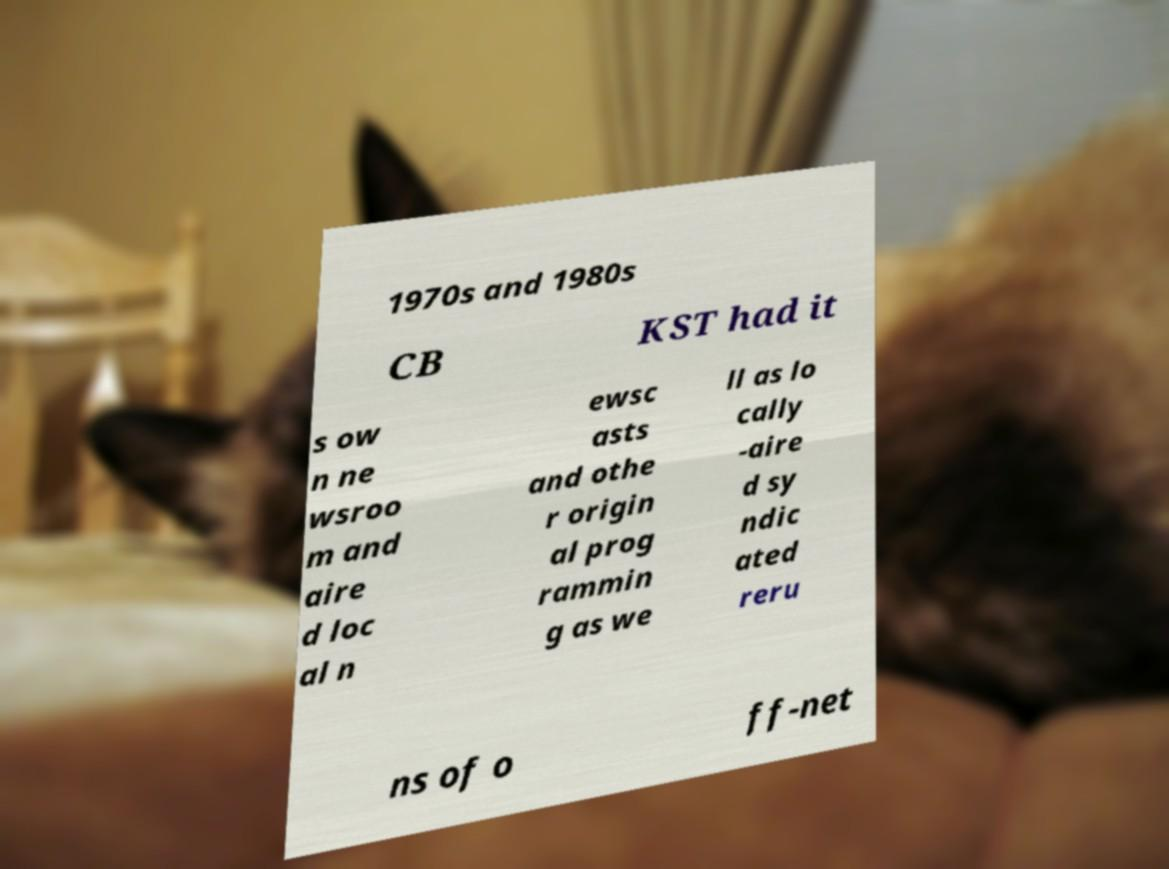Please read and relay the text visible in this image. What does it say? 1970s and 1980s CB KST had it s ow n ne wsroo m and aire d loc al n ewsc asts and othe r origin al prog rammin g as we ll as lo cally -aire d sy ndic ated reru ns of o ff-net 